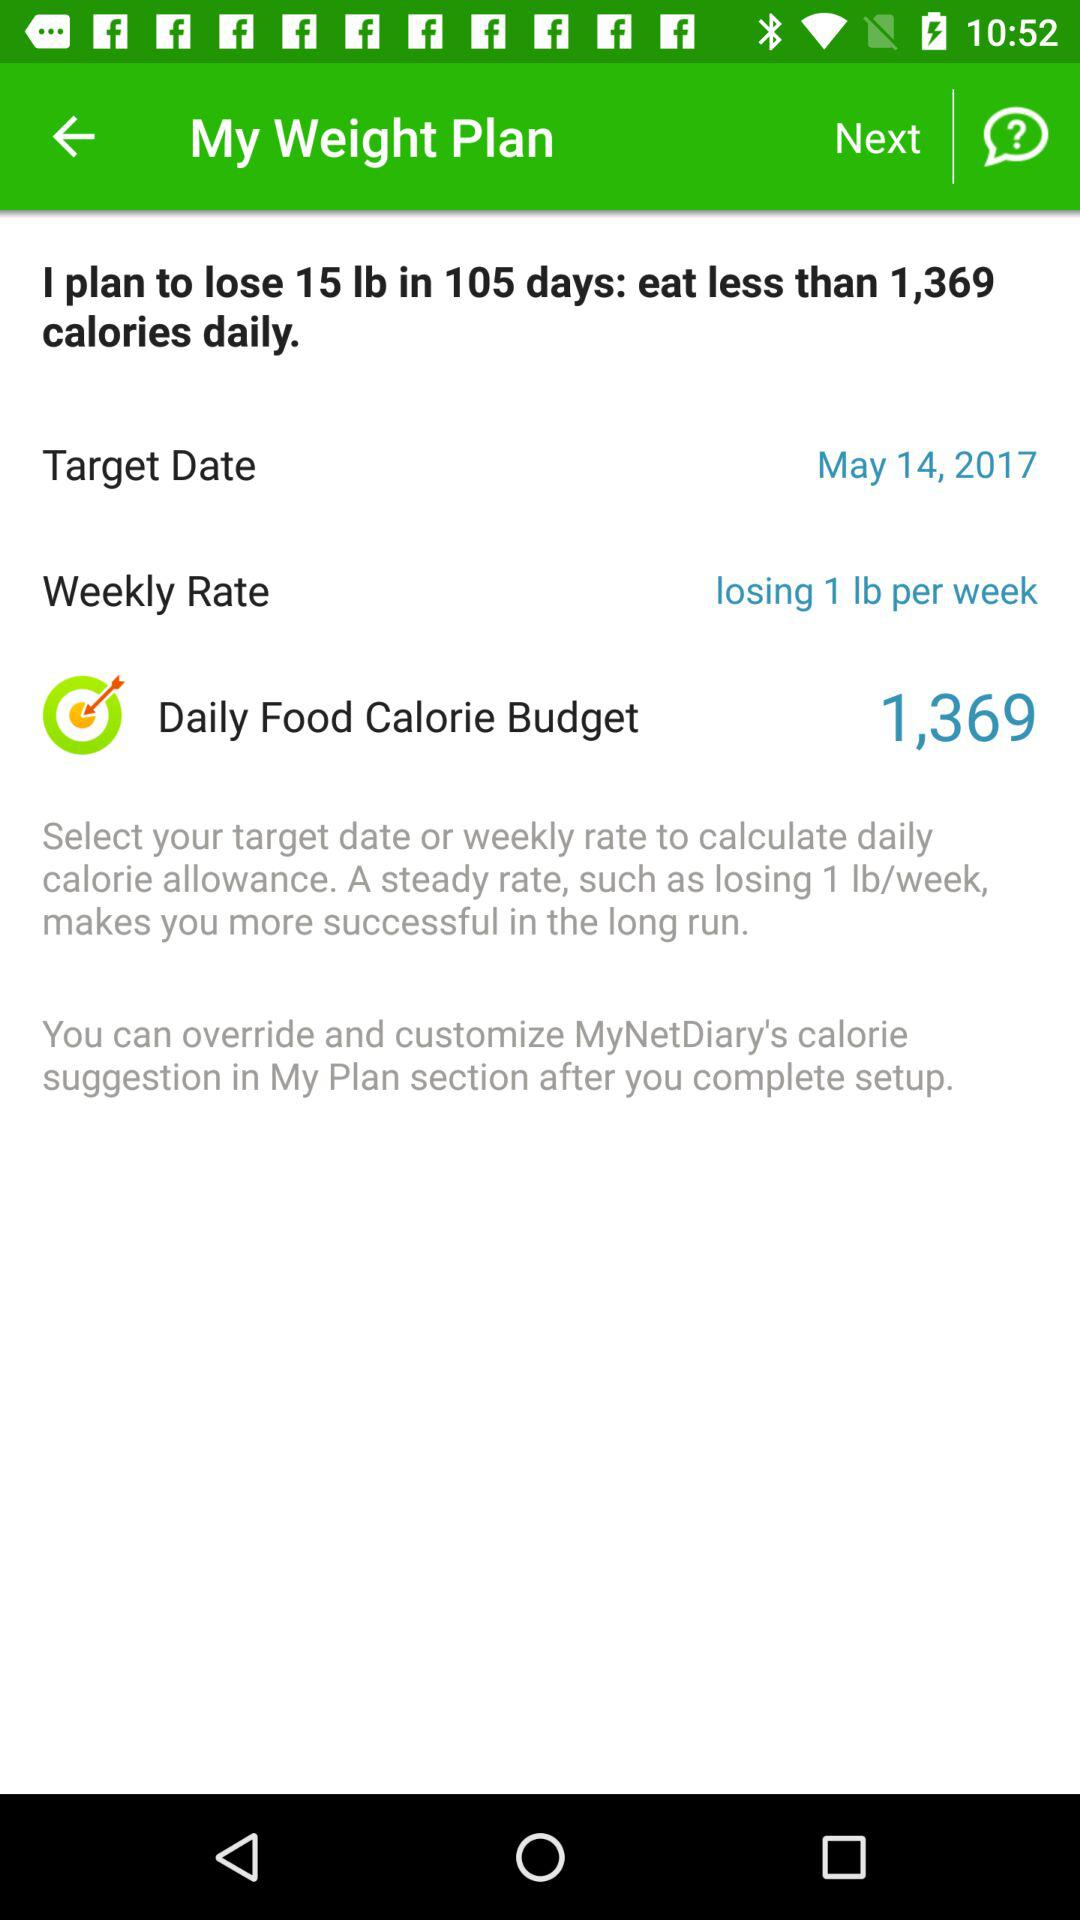What is the weekly rate? The weekly rate is losing 1 lb per week. 